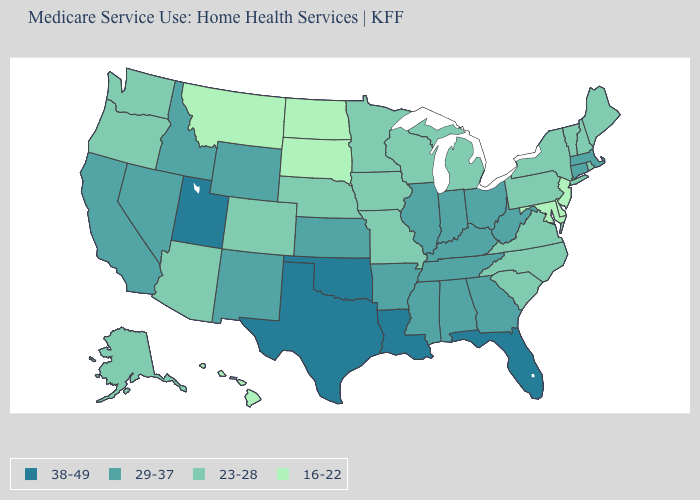Does the map have missing data?
Give a very brief answer. No. Name the states that have a value in the range 16-22?
Be succinct. Delaware, Hawaii, Maryland, Montana, New Jersey, North Dakota, South Dakota. What is the value of West Virginia?
Short answer required. 29-37. What is the value of Arizona?
Short answer required. 23-28. Among the states that border Maryland , does Virginia have the highest value?
Short answer required. No. What is the lowest value in the USA?
Short answer required. 16-22. Is the legend a continuous bar?
Concise answer only. No. What is the highest value in the USA?
Short answer required. 38-49. What is the value of Connecticut?
Quick response, please. 29-37. Name the states that have a value in the range 16-22?
Give a very brief answer. Delaware, Hawaii, Maryland, Montana, New Jersey, North Dakota, South Dakota. What is the value of New York?
Be succinct. 23-28. What is the lowest value in the Northeast?
Write a very short answer. 16-22. Among the states that border South Dakota , which have the highest value?
Quick response, please. Wyoming. Name the states that have a value in the range 16-22?
Keep it brief. Delaware, Hawaii, Maryland, Montana, New Jersey, North Dakota, South Dakota. 